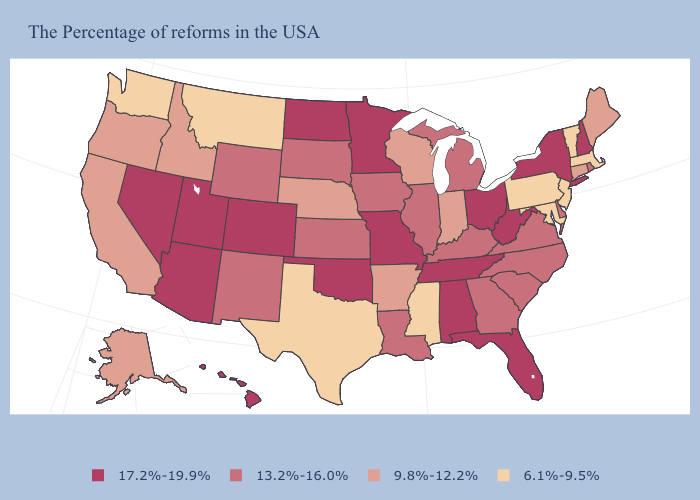Which states have the lowest value in the USA?
Short answer required. Massachusetts, Vermont, New Jersey, Maryland, Pennsylvania, Mississippi, Texas, Montana, Washington. Does Illinois have the highest value in the MidWest?
Concise answer only. No. What is the value of Idaho?
Give a very brief answer. 9.8%-12.2%. Does Minnesota have the highest value in the USA?
Write a very short answer. Yes. What is the highest value in states that border New Mexico?
Be succinct. 17.2%-19.9%. Among the states that border Virginia , does Tennessee have the highest value?
Give a very brief answer. Yes. Does Colorado have a higher value than Wisconsin?
Give a very brief answer. Yes. Among the states that border Iowa , does South Dakota have the highest value?
Answer briefly. No. Name the states that have a value in the range 9.8%-12.2%?
Give a very brief answer. Maine, Connecticut, Indiana, Wisconsin, Arkansas, Nebraska, Idaho, California, Oregon, Alaska. What is the highest value in the USA?
Give a very brief answer. 17.2%-19.9%. Which states have the highest value in the USA?
Be succinct. New Hampshire, New York, West Virginia, Ohio, Florida, Alabama, Tennessee, Missouri, Minnesota, Oklahoma, North Dakota, Colorado, Utah, Arizona, Nevada, Hawaii. Among the states that border Kansas , does Nebraska have the highest value?
Concise answer only. No. What is the value of Michigan?
Quick response, please. 13.2%-16.0%. Does the first symbol in the legend represent the smallest category?
Be succinct. No. Does Mississippi have the same value as Kansas?
Give a very brief answer. No. 